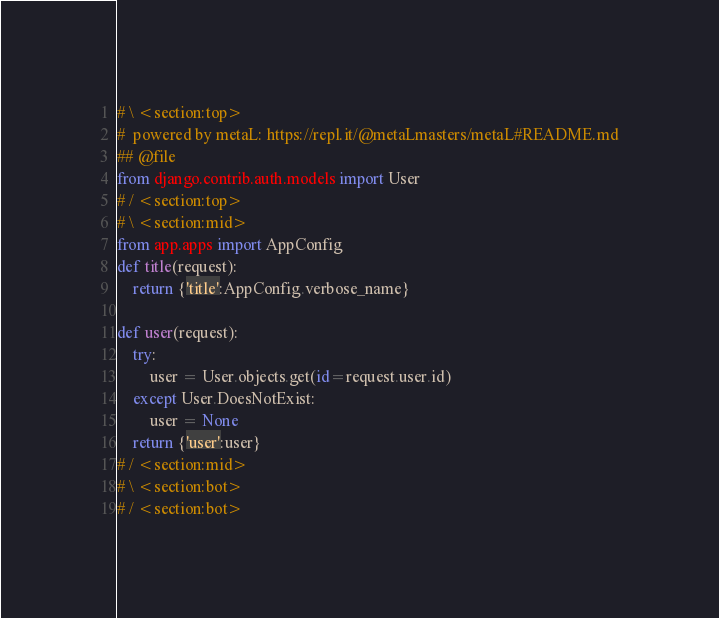<code> <loc_0><loc_0><loc_500><loc_500><_Python_>
# \ <section:top>
#  powered by metaL: https://repl.it/@metaLmasters/metaL#README.md
## @file
from django.contrib.auth.models import User
# / <section:top>
# \ <section:mid>
from app.apps import AppConfig
def title(request):
	return {'title':AppConfig.verbose_name}

def user(request):
	try:
		user = User.objects.get(id=request.user.id)
	except User.DoesNotExist:
		user = None
	return {'user':user}
# / <section:mid>
# \ <section:bot>
# / <section:bot></code> 